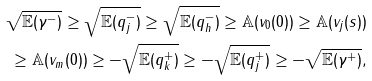Convert formula to latex. <formula><loc_0><loc_0><loc_500><loc_500>\sqrt { \mathbb { E } ( \gamma ^ { - } ) } \geq \sqrt { \mathbb { E } ( q _ { j } ^ { - } ) } \geq \sqrt { \mathbb { E } ( q _ { h } ^ { - } ) } \geq \mathbb { A } ( v _ { 0 } ( 0 ) ) \geq \mathbb { A } ( v _ { j } ( s ) ) \\ \geq \mathbb { A } ( v _ { m } ( 0 ) ) \geq - \sqrt { \mathbb { E } ( q _ { k } ^ { + } ) } \geq - \sqrt { \mathbb { E } ( q _ { j } ^ { + } ) } \geq - \sqrt { \mathbb { E } ( \gamma ^ { + } ) } ,</formula> 